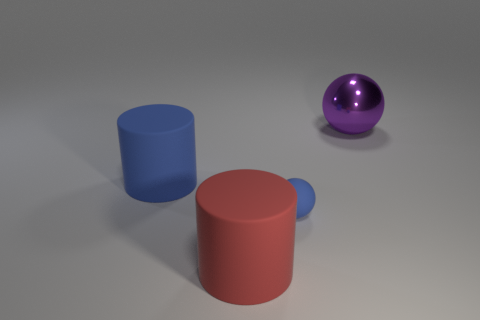What is the size of the sphere that is in front of the big metal thing?
Offer a terse response. Small. Are there any cylinders that have the same size as the purple metal thing?
Give a very brief answer. Yes. There is a ball that is left of the purple object; is it the same size as the big purple sphere?
Your response must be concise. No. What size is the blue matte ball?
Keep it short and to the point. Small. What color is the big cylinder to the left of the big object that is in front of the blue rubber thing on the left side of the big red rubber object?
Provide a succinct answer. Blue. Does the large cylinder that is left of the red rubber cylinder have the same color as the big metal thing?
Your answer should be very brief. No. What number of objects are behind the tiny blue rubber sphere and to the right of the red cylinder?
Give a very brief answer. 1. What size is the other thing that is the same shape as the small blue thing?
Keep it short and to the point. Large. There is a red rubber thing that is left of the ball that is in front of the purple thing; what number of big blue matte objects are on the left side of it?
Your answer should be compact. 1. There is a large cylinder that is on the left side of the big matte thing that is in front of the blue sphere; what color is it?
Your response must be concise. Blue. 